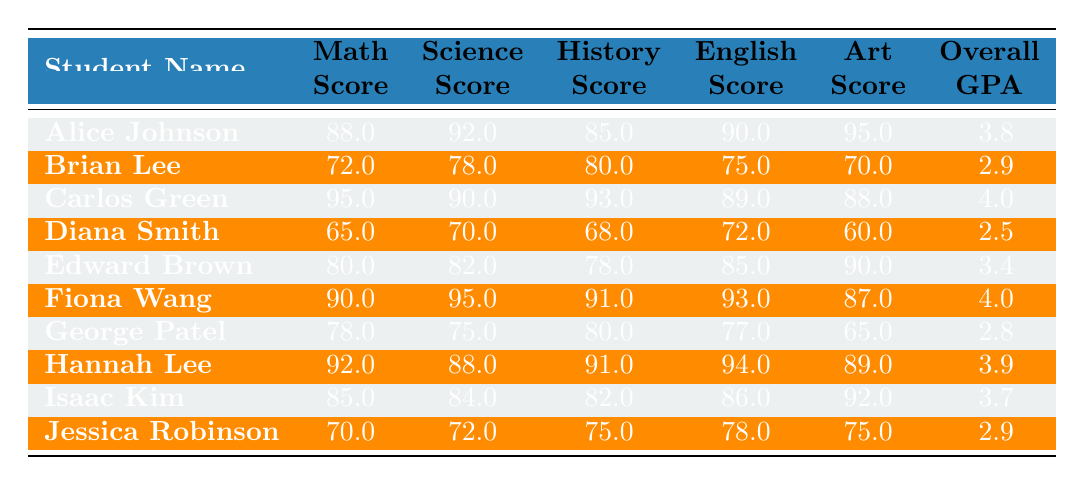What was Alice Johnson's math test score? Alice Johnson’s math test score can be found in the table under the "Math Score" column for her row. It is listed as 88.0.
Answer: 88.0 What is the overall GPA of Carlos Green? The overall GPA for Carlos Green is directly listed in the "Overall GPA" column in his row, which is 4.0.
Answer: 4.0 Which student had the lowest score in the art final? By reviewing the "Art Final Score" column, it is clear that Diana Smith had the lowest score of 60.0.
Answer: Diana Smith What is the average math test score for all students? To calculate the average math test score, sum all the scores (88 + 72 + 95 + 65 + 80 + 90 + 78 + 92 + 85 + 70 =  850) and divide by the number of students (10). The average is 850 / 10 = 85.0.
Answer: 85.0 Did any student score above 90 in all subjects? By looking at the table, no student has scores above 90 across all subjects. The highest scores do not appear across all subjects simultaneously.
Answer: No Which student's overall GPA is the highest? Reviewing the "Overall GPA" column shows that both Carlos Green and Fiona Wang have the highest GPA of 4.0, making them the top two students in this category.
Answer: Carlos Green and Fiona Wang What is the difference between the highest and lowest overall GPA? The highest overall GPA is 4.0 (Carlos Green or Fiona Wang) and the lowest is 2.5 (Diana Smith). Thus, the difference is 4.0 - 2.5 = 1.5.
Answer: 1.5 What percentage of students scored above 80 in science? There are 10 students, and the ones who scored above 80 in science are Alice Johnson, Carlos Green, Fiona Wang, Hannah Lee, and Isaac Kim (5 students). Therefore, the percentage is (5/10) * 100 = 50%.
Answer: 50% What is the median score for English test scores? The English scores, when sorted, are 72, 75, 77, 78, 85, 89, 90, 93, 94, 86. The median is the average of the 5th and 6th scores (85 and 89), which is (85 + 89) / 2 = 87.0.
Answer: 87.0 Which student had the highest score in history? By checking the "History Score" column, Carlos Green has the highest score of 93.0.
Answer: Carlos Green 